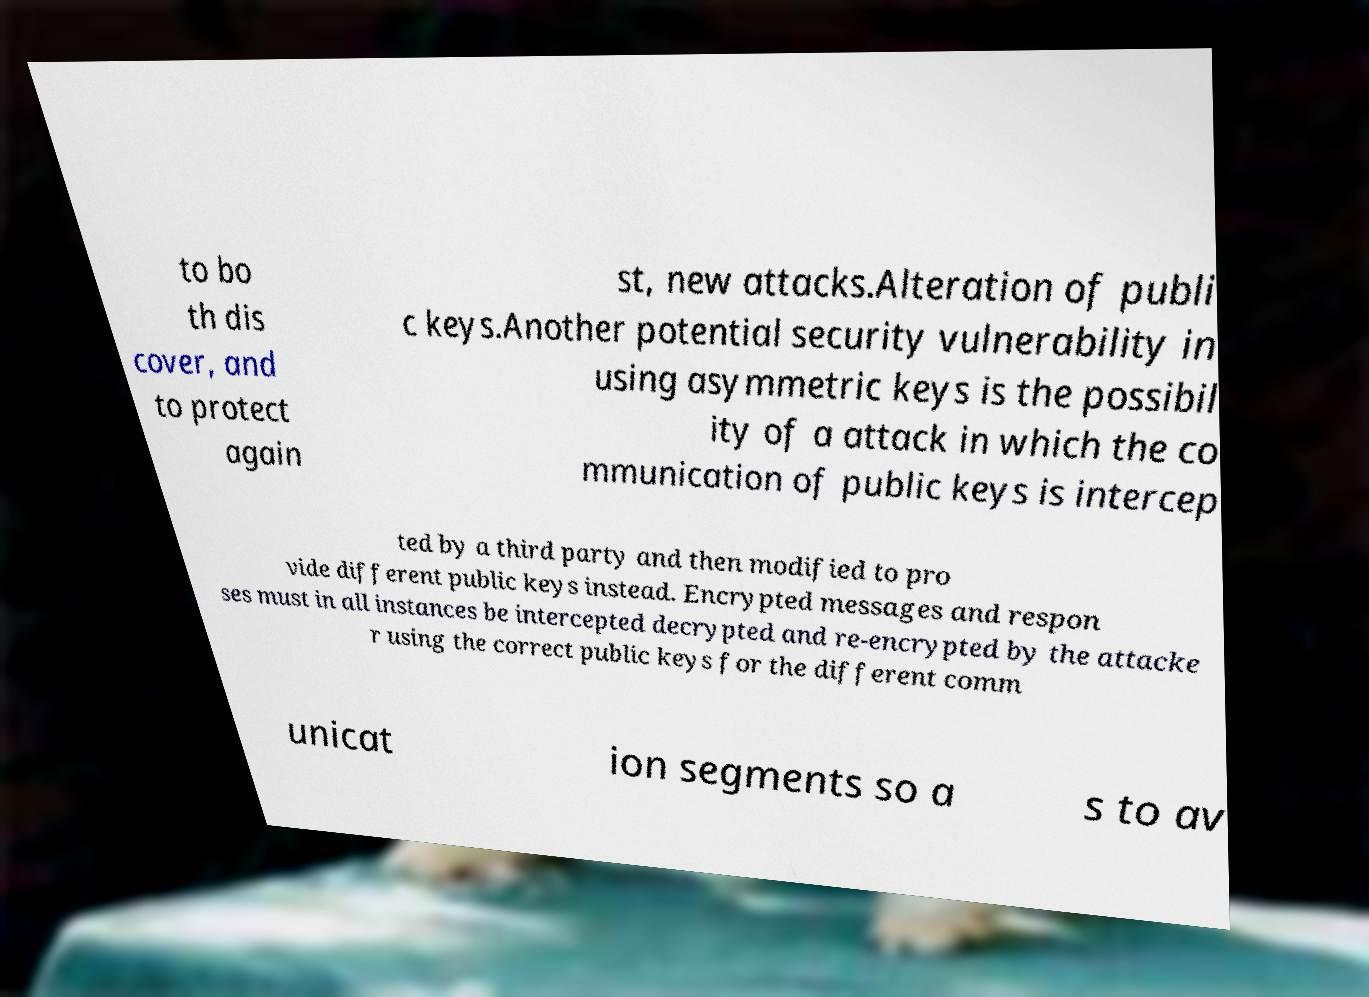Can you read and provide the text displayed in the image?This photo seems to have some interesting text. Can you extract and type it out for me? to bo th dis cover, and to protect again st, new attacks.Alteration of publi c keys.Another potential security vulnerability in using asymmetric keys is the possibil ity of a attack in which the co mmunication of public keys is intercep ted by a third party and then modified to pro vide different public keys instead. Encrypted messages and respon ses must in all instances be intercepted decrypted and re-encrypted by the attacke r using the correct public keys for the different comm unicat ion segments so a s to av 